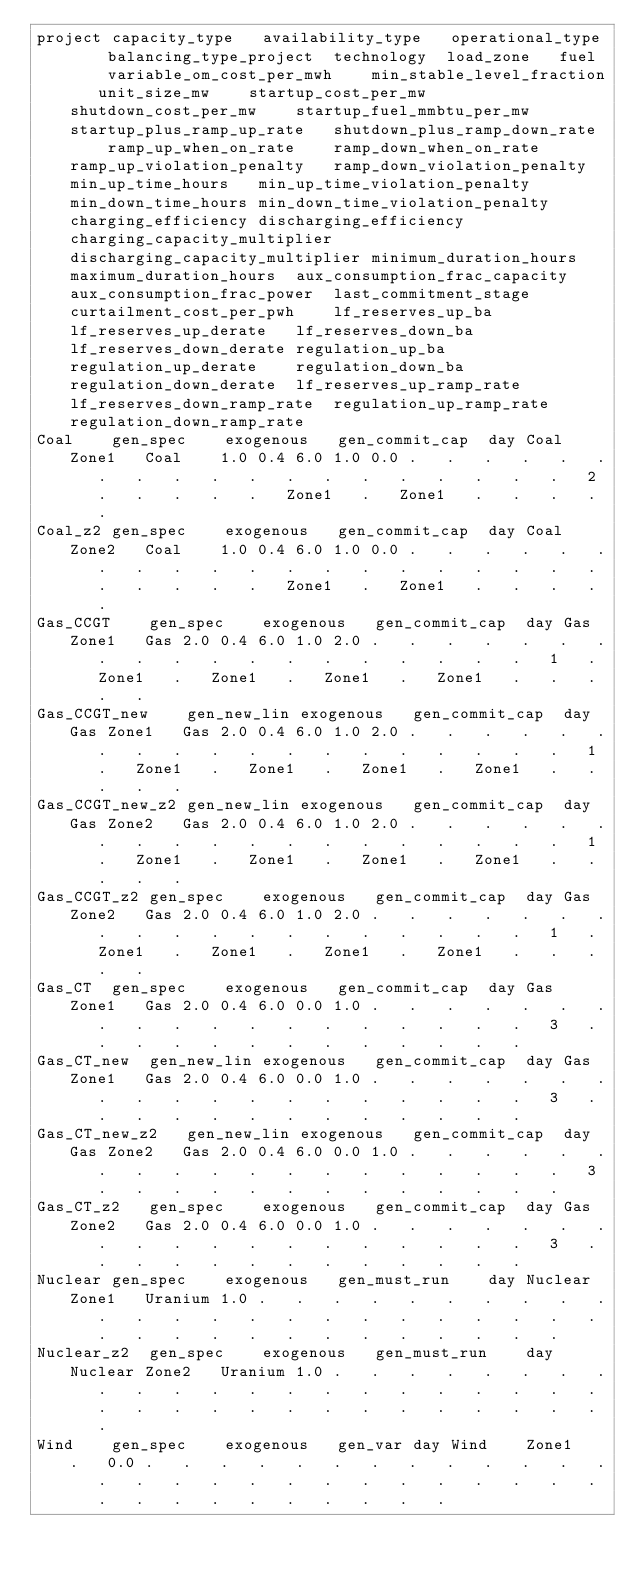<code> <loc_0><loc_0><loc_500><loc_500><_SQL_>project	capacity_type	availability_type	operational_type	balancing_type_project	technology	load_zone	fuel	variable_om_cost_per_mwh	min_stable_level_fraction	unit_size_mw	startup_cost_per_mw	shutdown_cost_per_mw	startup_fuel_mmbtu_per_mw	startup_plus_ramp_up_rate	shutdown_plus_ramp_down_rate	ramp_up_when_on_rate	ramp_down_when_on_rate	ramp_up_violation_penalty	ramp_down_violation_penalty	min_up_time_hours	min_up_time_violation_penalty	min_down_time_hours	min_down_time_violation_penalty	charging_efficiency	discharging_efficiency	charging_capacity_multiplier	discharging_capacity_multiplier	minimum_duration_hours	maximum_duration_hours	aux_consumption_frac_capacity	aux_consumption_frac_power	last_commitment_stage	curtailment_cost_per_pwh	lf_reserves_up_ba	lf_reserves_up_derate	lf_reserves_down_ba	lf_reserves_down_derate	regulation_up_ba	regulation_up_derate	regulation_down_ba	regulation_down_derate	lf_reserves_up_ramp_rate	lf_reserves_down_ramp_rate	regulation_up_ramp_rate	regulation_down_ramp_rate
Coal	gen_spec	exogenous	gen_commit_cap	day	Coal	Zone1	Coal	1.0	0.4	6.0	1.0	0.0	.	.	.	.	.	.	.	.	.	.	.	.	.	.	.	.	.	.	.	2	.	.	.	.	.	Zone1	.	Zone1	.	.	.	.	.
Coal_z2	gen_spec	exogenous	gen_commit_cap	day	Coal	Zone2	Coal	1.0	0.4	6.0	1.0	0.0	.	.	.	.	.	.	.	.	.	.	.	.	.	.	.	.	.	.	.	.	.	.	.	.	.	Zone1	.	Zone1	.	.	.	.	.
Gas_CCGT	gen_spec	exogenous	gen_commit_cap	day	Gas	Zone1	Gas	2.0	0.4	6.0	1.0	2.0	.	.	.	.	.	.	.	.	.	.	.	.	.	.	.	.	.	.	.	1	.	Zone1	.	Zone1	.	Zone1	.	Zone1	.	.	.	.	.
Gas_CCGT_new	gen_new_lin	exogenous	gen_commit_cap	day	Gas	Zone1	Gas	2.0	0.4	6.0	1.0	2.0	.	.	.	.	.	.	.	.	.	.	.	.	.	.	.	.	.	.	.	1	.	Zone1	.	Zone1	.	Zone1	.	Zone1	.	.	.	.	.
Gas_CCGT_new_z2	gen_new_lin	exogenous	gen_commit_cap	day	Gas	Zone2	Gas	2.0	0.4	6.0	1.0	2.0	.	.	.	.	.	.	.	.	.	.	.	.	.	.	.	.	.	.	.	1	.	Zone1	.	Zone1	.	Zone1	.	Zone1	.	.	.	.	.
Gas_CCGT_z2	gen_spec	exogenous	gen_commit_cap	day	Gas	Zone2	Gas	2.0	0.4	6.0	1.0	2.0	.	.	.	.	.	.	.	.	.	.	.	.	.	.	.	.	.	.	.	1	.	Zone1	.	Zone1	.	Zone1	.	Zone1	.	.	.	.	.
Gas_CT	gen_spec	exogenous	gen_commit_cap	day	Gas	Zone1	Gas	2.0	0.4	6.0	0.0	1.0	.	.	.	.	.	.	.	.	.	.	.	.	.	.	.	.	.	.	.	3	.	.	.	.	.	.	.	.	.	.	.	.	.
Gas_CT_new	gen_new_lin	exogenous	gen_commit_cap	day	Gas	Zone1	Gas	2.0	0.4	6.0	0.0	1.0	.	.	.	.	.	.	.	.	.	.	.	.	.	.	.	.	.	.	.	3	.	.	.	.	.	.	.	.	.	.	.	.	.
Gas_CT_new_z2	gen_new_lin	exogenous	gen_commit_cap	day	Gas	Zone2	Gas	2.0	0.4	6.0	0.0	1.0	.	.	.	.	.	.	.	.	.	.	.	.	.	.	.	.	.	.	.	3	.	.	.	.	.	.	.	.	.	.	.	.	.
Gas_CT_z2	gen_spec	exogenous	gen_commit_cap	day	Gas	Zone2	Gas	2.0	0.4	6.0	0.0	1.0	.	.	.	.	.	.	.	.	.	.	.	.	.	.	.	.	.	.	.	3	.	.	.	.	.	.	.	.	.	.	.	.	.
Nuclear	gen_spec	exogenous	gen_must_run	day	Nuclear	Zone1	Uranium	1.0	.	.	.	.	.	.	.	.	.	.	.	.	.	.	.	.	.	.	.	.	.	.	.	.	.	.	.	.	.	.	.	.	.	.	.	.	.
Nuclear_z2	gen_spec	exogenous	gen_must_run	day	Nuclear	Zone2	Uranium	1.0	.	.	.	.	.	.	.	.	.	.	.	.	.	.	.	.	.	.	.	.	.	.	.	.	.	.	.	.	.	.	.	.	.	.	.	.	.
Wind	gen_spec	exogenous	gen_var	day	Wind	Zone1	.	0.0	.	.	.	.	.	.	.	.	.	.	.	.	.	.	.	.	.	.	.	.	.	.	.	.	.	.	.	.	.	.	.	.	.	.	.	.	.</code> 